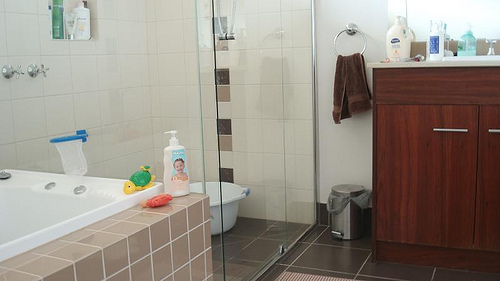Please provide a short description for this region: [0.83, 0.44, 0.99, 0.46]. Another blue and white container placed on the bathtub's edge. 